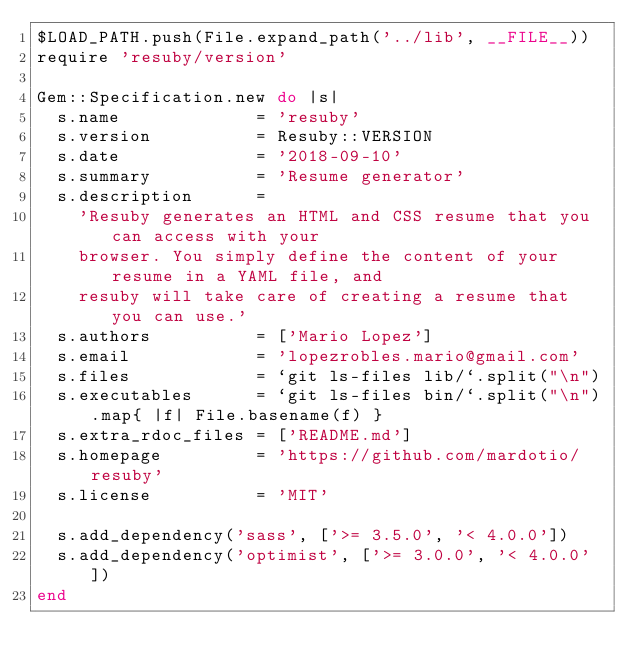<code> <loc_0><loc_0><loc_500><loc_500><_Ruby_>$LOAD_PATH.push(File.expand_path('../lib', __FILE__))
require 'resuby/version'

Gem::Specification.new do |s|
  s.name             = 'resuby'
  s.version          = Resuby::VERSION
  s.date             = '2018-09-10'
  s.summary          = 'Resume generator'
  s.description      =
    'Resuby generates an HTML and CSS resume that you can access with your
    browser. You simply define the content of your resume in a YAML file, and
    resuby will take care of creating a resume that you can use.'
  s.authors          = ['Mario Lopez']
  s.email            = 'lopezrobles.mario@gmail.com'
  s.files            = `git ls-files lib/`.split("\n")
  s.executables      = `git ls-files bin/`.split("\n").map{ |f| File.basename(f) }
  s.extra_rdoc_files = ['README.md']
  s.homepage         = 'https://github.com/mardotio/resuby'
  s.license          = 'MIT'

  s.add_dependency('sass', ['>= 3.5.0', '< 4.0.0'])
  s.add_dependency('optimist', ['>= 3.0.0', '< 4.0.0'])
end
</code> 